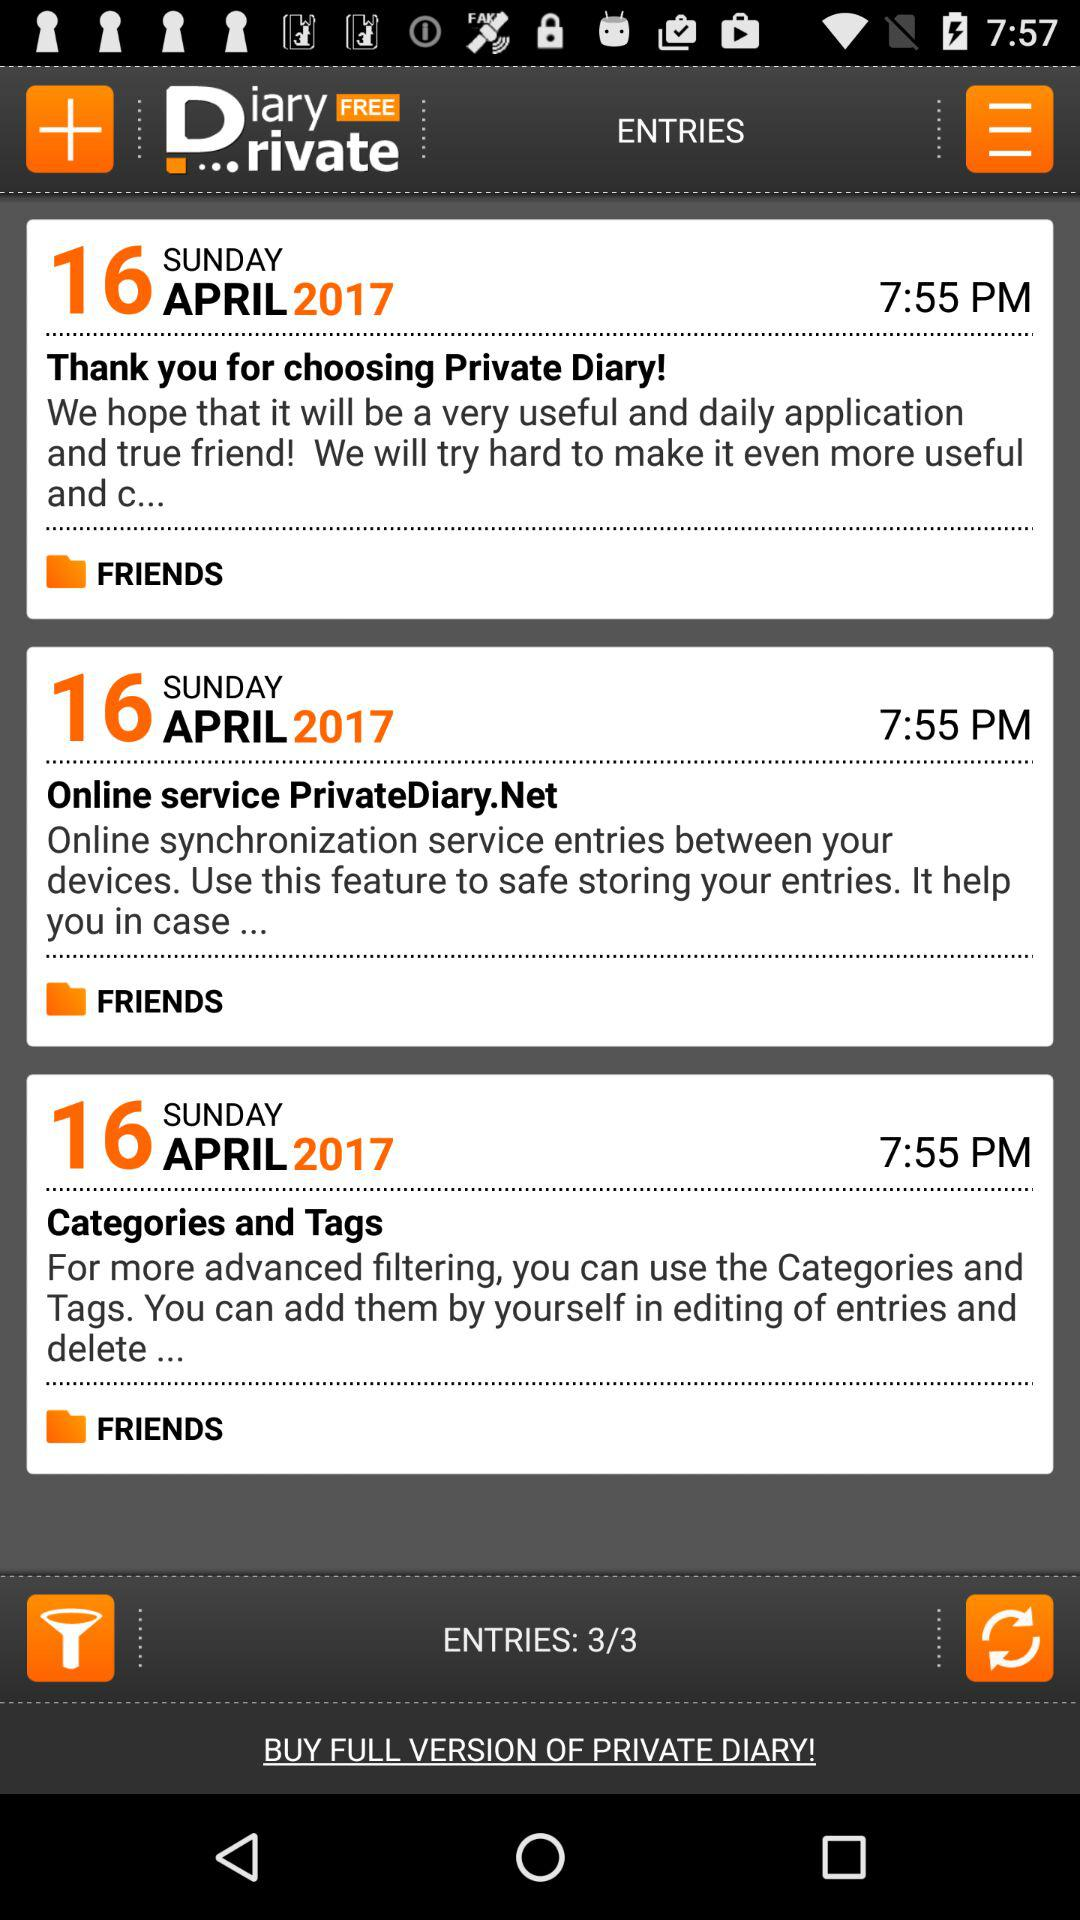Which day falls on April 16, 2017? The day is Sunday. 